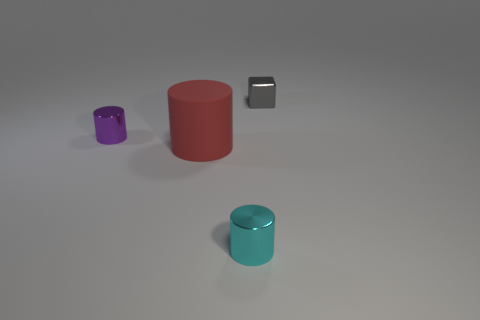Add 2 tiny cyan metal things. How many objects exist? 6 Subtract all cubes. How many objects are left? 3 Subtract 1 purple cylinders. How many objects are left? 3 Subtract all small green metal spheres. Subtract all tiny metallic objects. How many objects are left? 1 Add 3 small gray shiny objects. How many small gray shiny objects are left? 4 Add 3 cylinders. How many cylinders exist? 6 